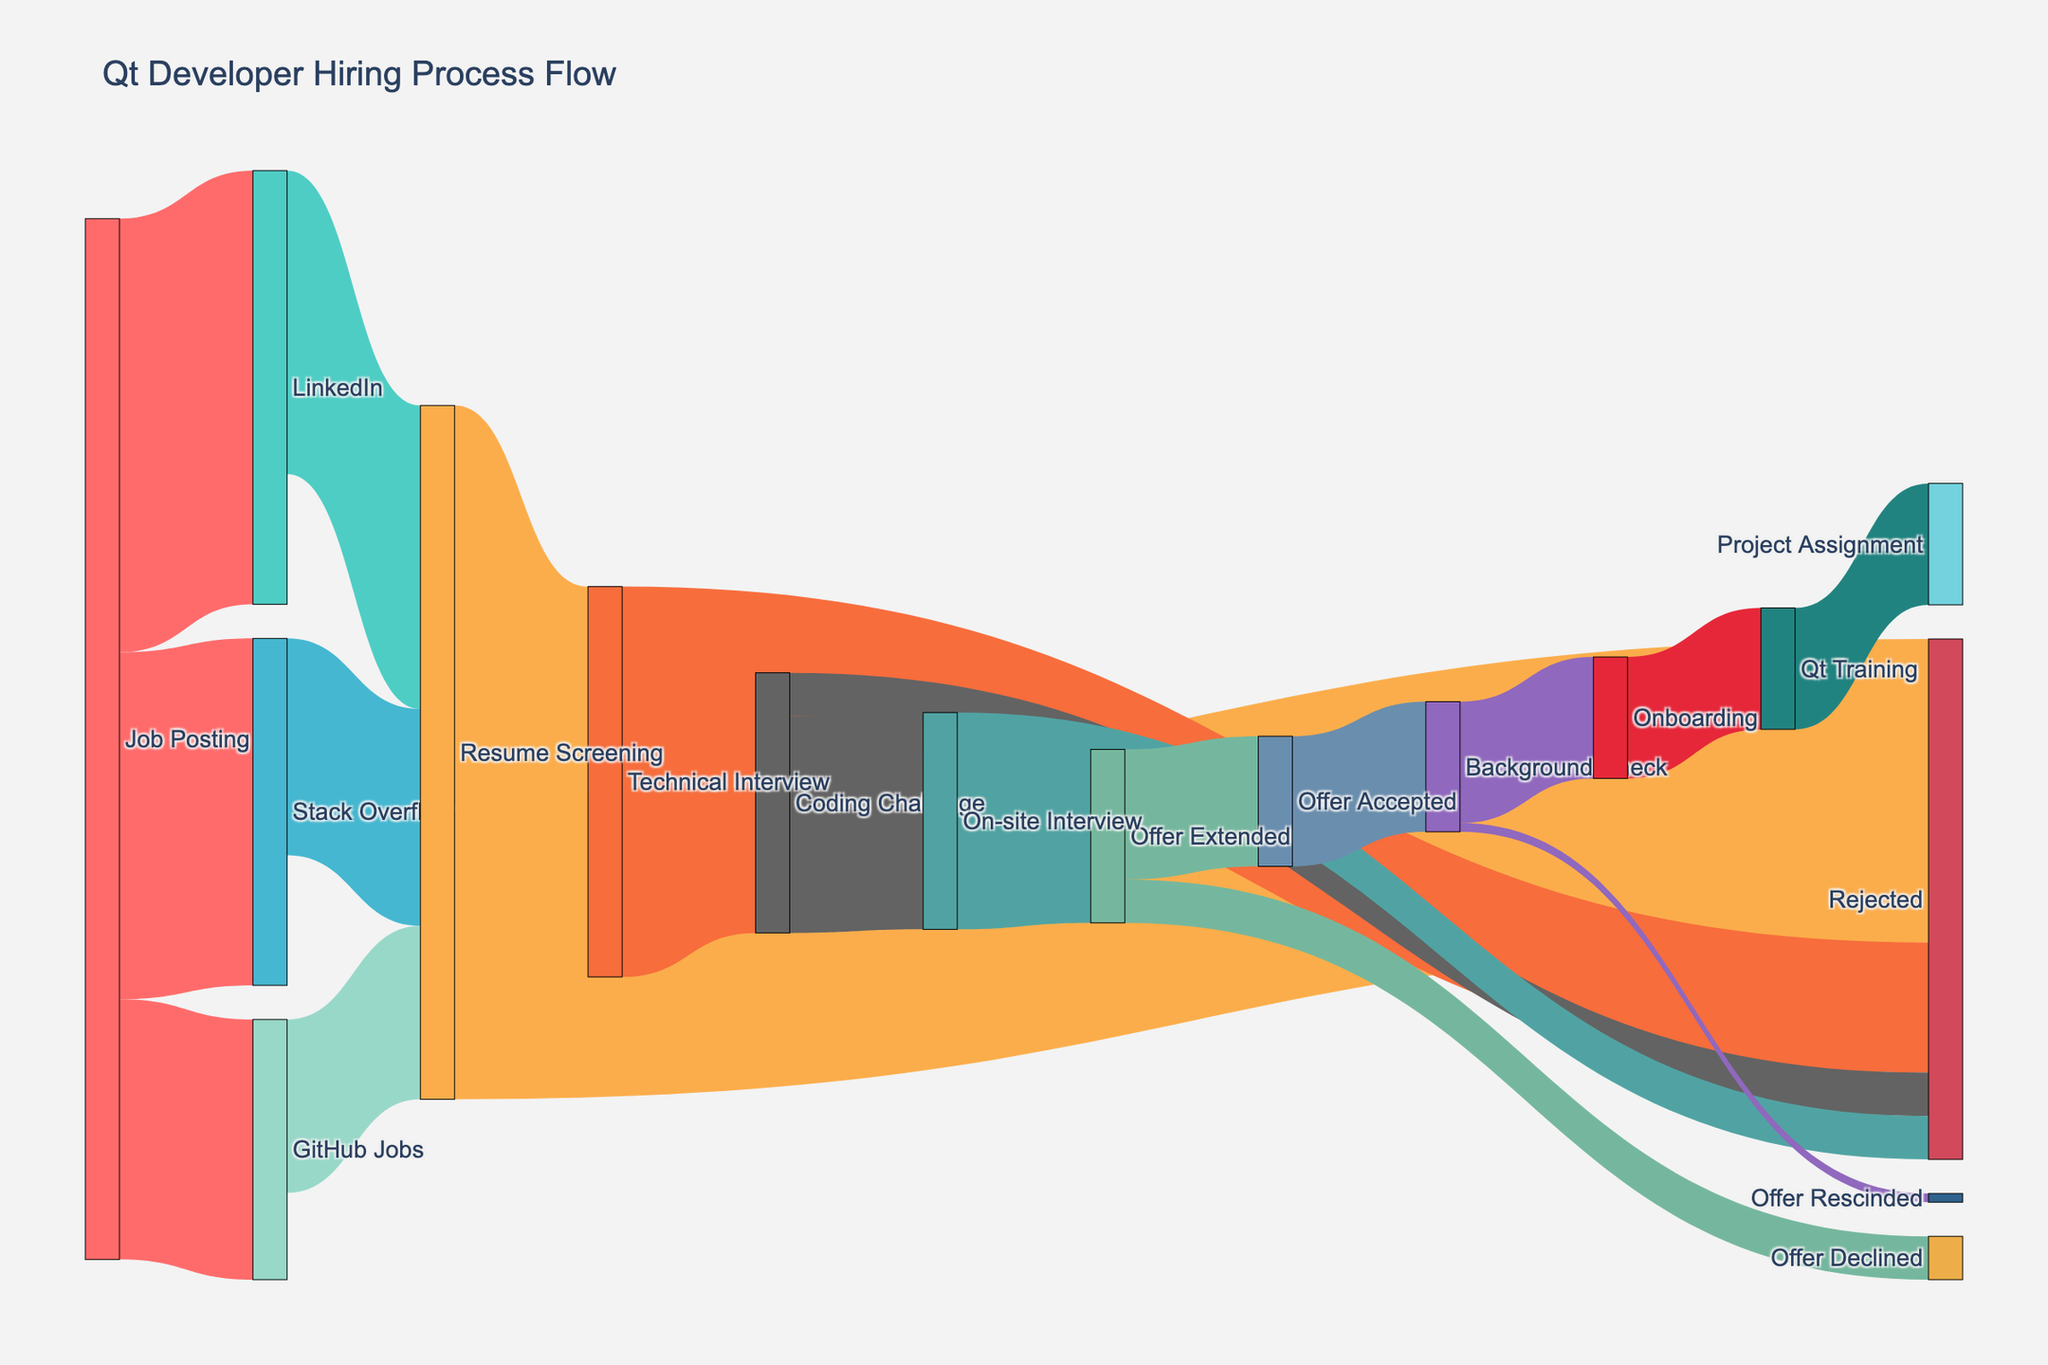Where do most resumes come from? By looking at the thickest lines coming from different job posting platforms to "Resume Screening", LinkedIn contributes the most with 35 resumes.
Answer: LinkedIn How many candidates were rejected during the resume screening process? By checking the flow from "Resume Screening" to "Rejected", the value is 35.
Answer: 35 Compare the number of candidates that moved from Technical Interview to Coding Challenge versus those who were rejected from Technical Interview. There are 30 candidates moving to Coding Challenge and 15 candidates being rejected from Technical Interview.
Answer: 30 vs 15 How many candidates made it to the Onboarding phase? Follow the flow to the "Onboarding" node, which has 14 candidates from "Background Check".
Answer: 14 Which phase has the highest drop in candidate numbers? The highest drop is from "Job Posting" to "Resume Screening", comparing non-rejected candidates. The numbers go from 120 initially to 45 screened, resulting in the largest drop of 75.
Answer: Resume Screening What percentage of offers extended were accepted? Out of 20 offers extended, 15 were accepted. The percentage is calculated as (15/20) * 100 = 75%.
Answer: 75% What is the total number of candidates who went through the Technical Interview? Sum up the candidates proceeding to "Coding Challenge" (30) and those rejected (15), totaling 45.
Answer: 45 From the candidates who accepted the offer, how many ended up getting rescinded during the Background Check process? The value of the flow "Background Check" to "Offer Rescinded" is 1.
Answer: 1 What flow has the smallest number of candidates? The smallest value is 1 for the flow from "Background Check" to "Offer Rescinded".
Answer: 1 How many candidates were initially sourced from job postings? Sum the three initial flows: LinkedIn (50), Stack Overflow (40), and GitHub Jobs (30), resulting in 120 candidates.
Answer: 120 